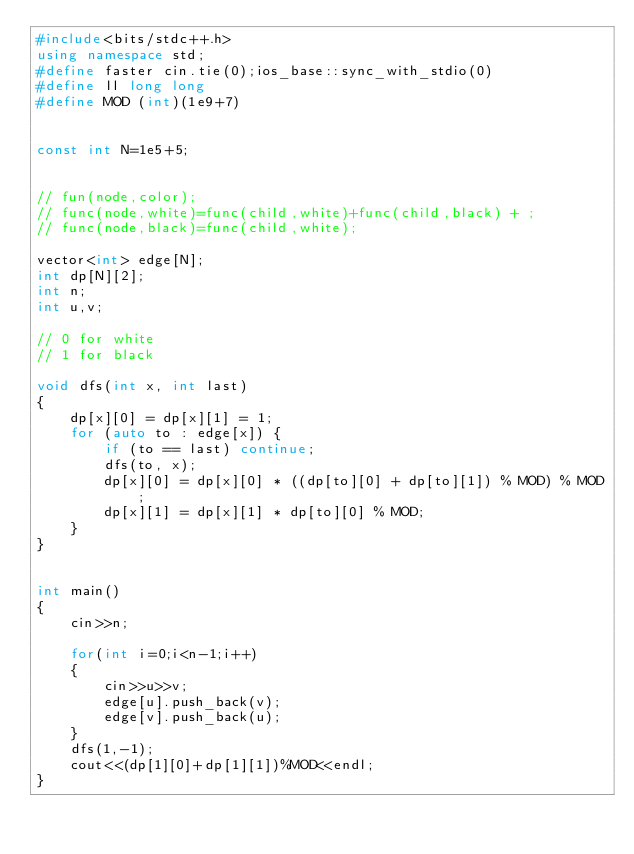Convert code to text. <code><loc_0><loc_0><loc_500><loc_500><_C++_>#include<bits/stdc++.h>
using namespace std;
#define faster cin.tie(0);ios_base::sync_with_stdio(0)
#define ll long long
#define MOD (int)(1e9+7)


const int N=1e5+5;


// fun(node,color);
// func(node,white)=func(child,white)+func(child,black) + ;
// func(node,black)=func(child,white);

vector<int> edge[N];
int dp[N][2];
int n;
int u,v;

// 0 for white
// 1 for black

void dfs(int x, int last)
{
	dp[x][0] = dp[x][1] = 1;
	for (auto to : edge[x]) {
		if (to == last) continue;
		dfs(to, x);
		dp[x][0] = dp[x][0] * ((dp[to][0] + dp[to][1]) % MOD) % MOD;
		dp[x][1] = dp[x][1] * dp[to][0] % MOD;
	}
}
 

int main()
{
	cin>>n;
	
	for(int i=0;i<n-1;i++)
	{
		cin>>u>>v;
		edge[u].push_back(v);
		edge[v].push_back(u);
	}
	dfs(1,-1);
	cout<<(dp[1][0]+dp[1][1])%MOD<<endl;
}
	
</code> 